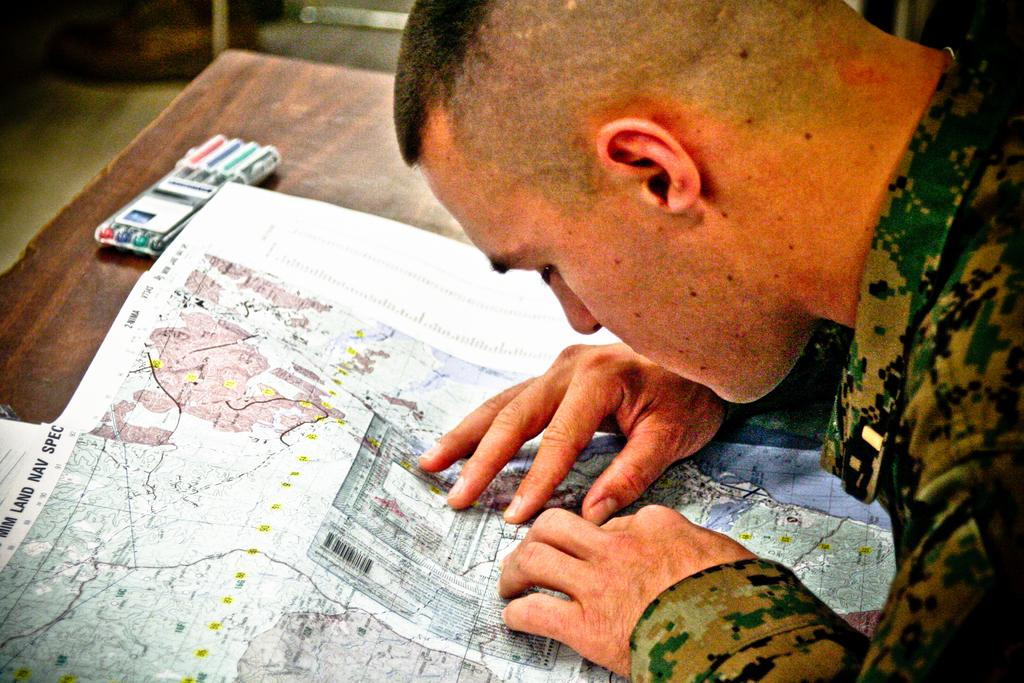Who is present in the image? There is a man in the image. What is the man doing in the image? The man is looking at a map in the image. Are there any objects on the table in the image? There may be pens on the table in the image. What is the man's top fear in the image? There is no information about the man's fears in the image, so it cannot be determined. 